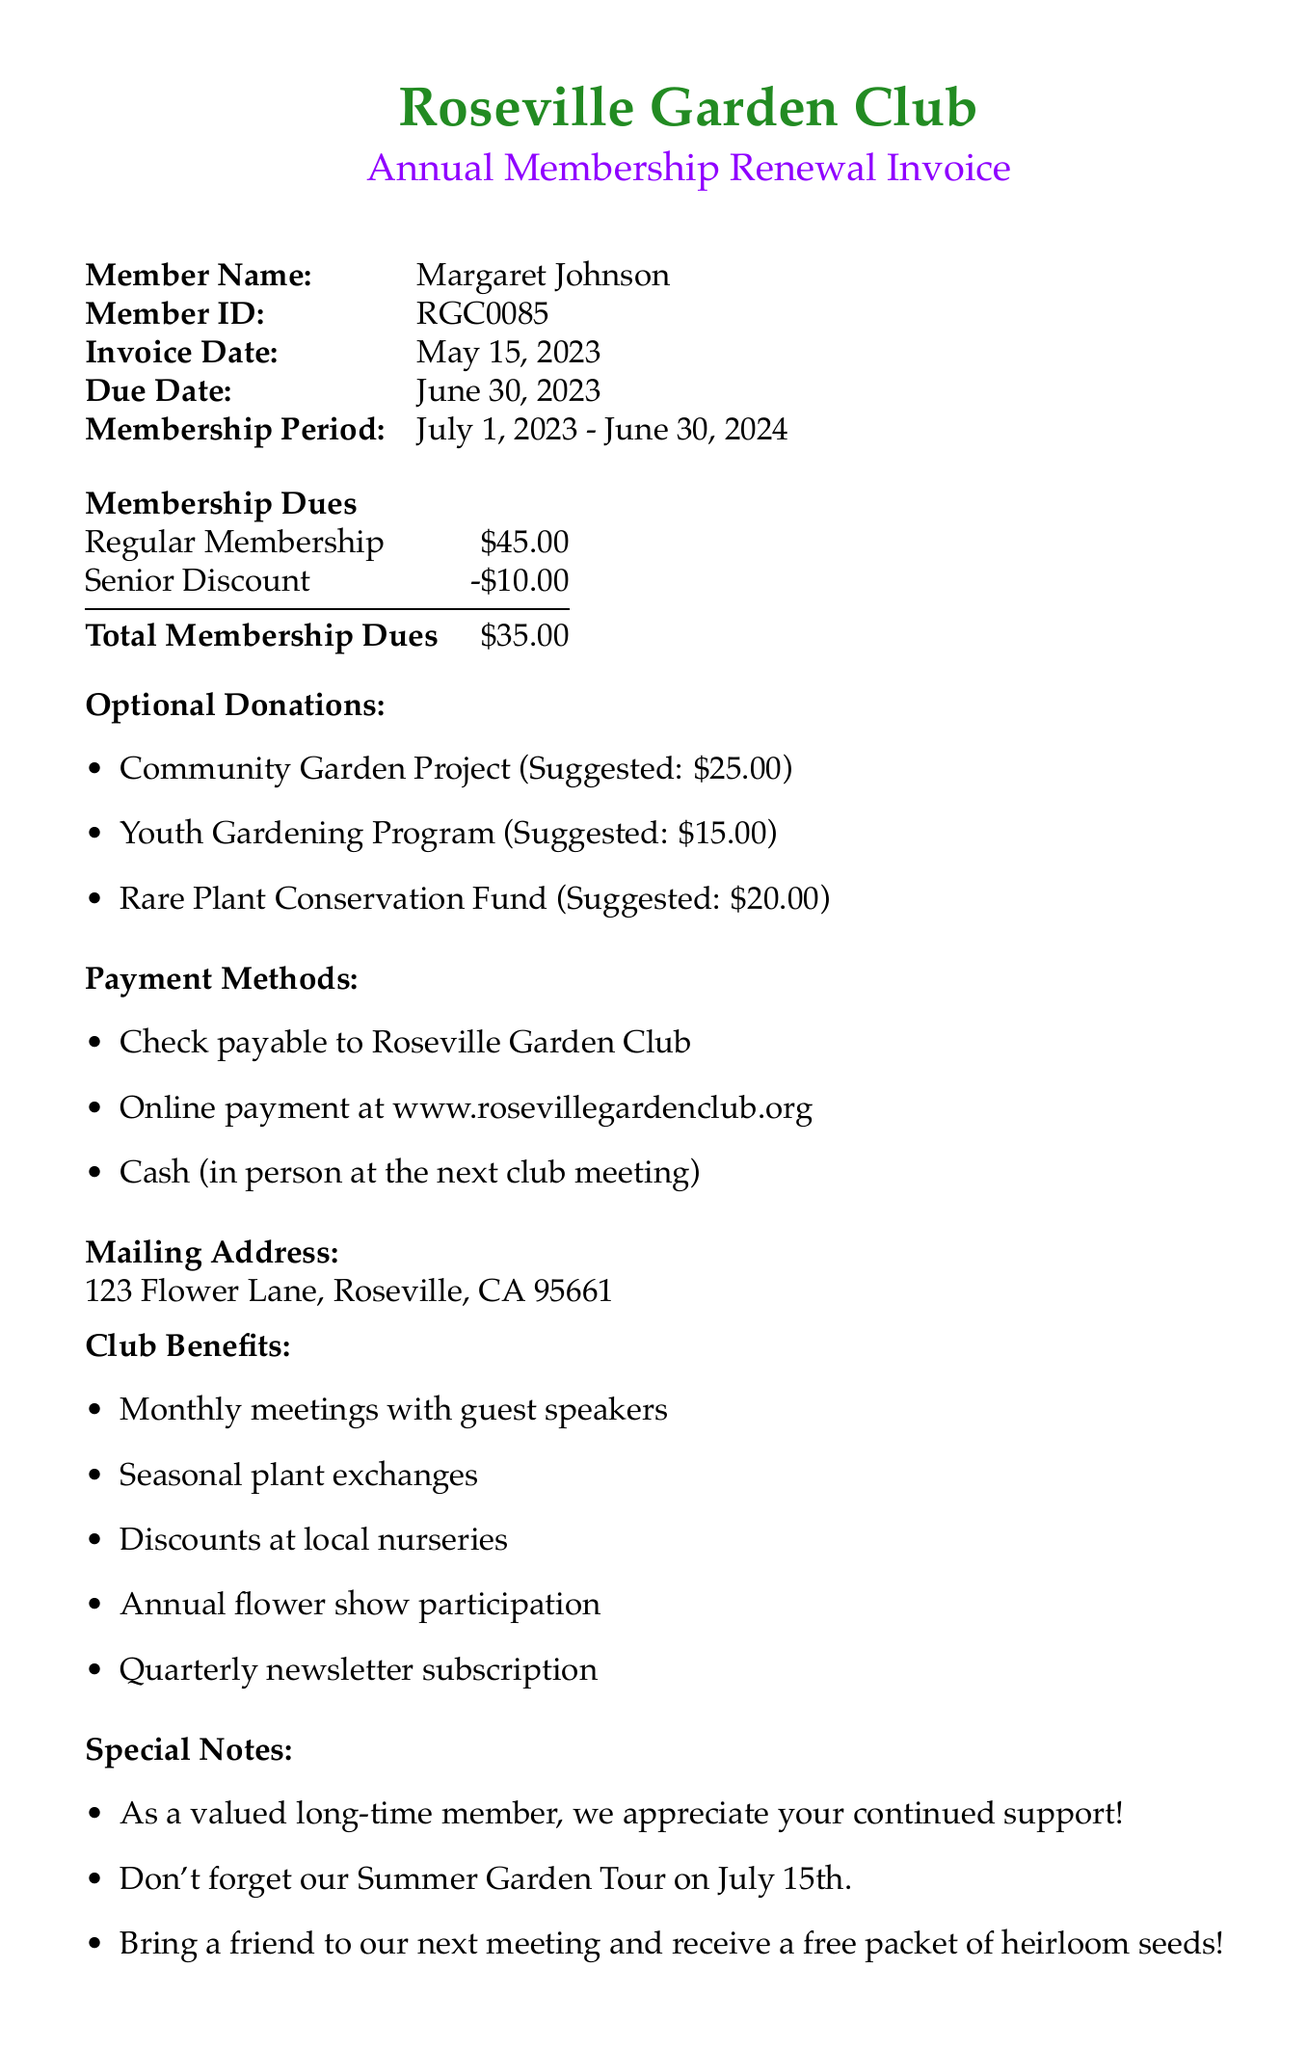What is the name of the organization? The name of the organization is mentioned prominently at the top of the invoice.
Answer: Roseville Garden Club What is the member ID? The member ID is provided as a unique identifier for the member.
Answer: RGC0085 What is the total membership dues after applying the senior discount? The total membership dues calculation is shown in the dues section by subtracting the discount from the regular fee.
Answer: $35.00 What is the suggested amount for the Community Garden Project? The suggested amount for optional donations is listed under the donation section.
Answer: $25.00 What is the due date for the invoice? The due date is explicitly stated in the document and is important for payment purposes.
Answer: June 30, 2023 How many optional donation categories are listed? The document lists multiple categories for optional donations, which can be counted for this question.
Answer: 3 Who is the Treasurer of the Roseville Garden Club? The contact information section specifies who the Treasurer is.
Answer: Barbara Smith What event is mentioned to occur on July 15th? The special notes indicate a specific upcoming event that members should be aware of.
Answer: Summer Garden Tour What payment methods are available? The payment methods are detailed in a list format within the document.
Answer: Check, Online payment, Cash What are the benefits of club membership? The club benefits are outlined with a list to inform members of their advantages.
Answer: Monthly meetings, plant exchanges, discounts, flower show, newsletter 